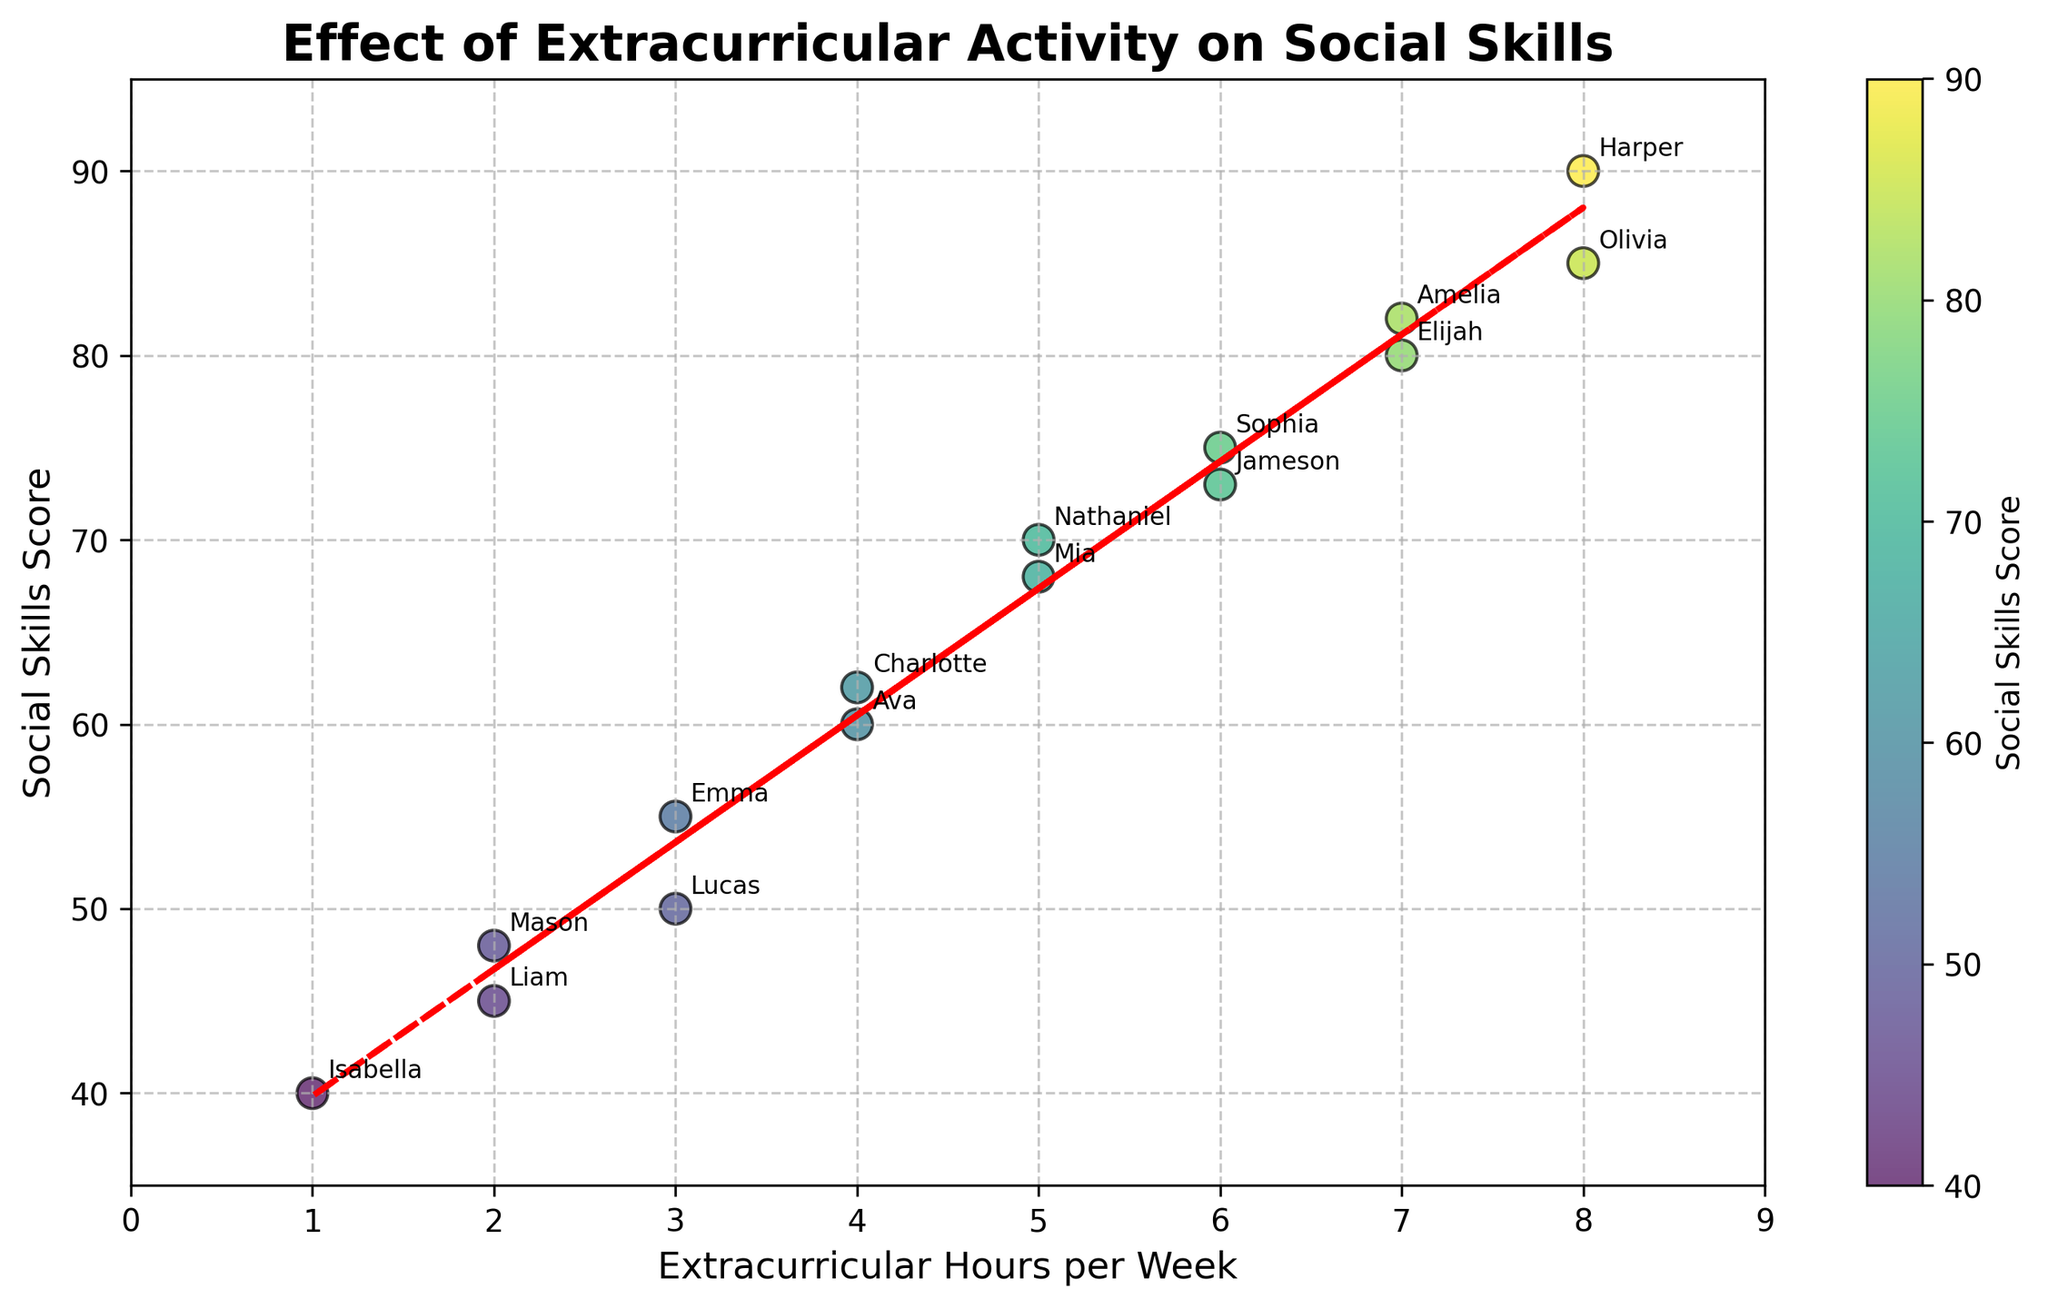How many data points are on the plot? Count the number of children listed in the data.
Answer: 15 What's the title of the plot? Read the title displayed at the top of the plot.
Answer: Effect of Extracurricular Activity on Social Skills Which axis indicates extracurricular hours per week? Determine which axis (horizontal or vertical) is labeled with "Extracurricular Hours per Week".
Answer: Horizontal (x-axis) Which child has the highest Social Skills Score? Look at all the data points and find the one with the highest score on the vertical axis.
Answer: Harper How many extracurricular hours does the child with the lowest Social Skills Score participate in? Identify the child with the lowest social skills score, then check their corresponding extracurricular hours on the horizontal axis.
Answer: 1 hour (Isabella) On average, how many extracurricular hours do children with a Social Skills Score above 75 participate in? Identify children with scores above 75, sum their extracurricular hours, and divide by the number of such children. The children are Olivia, Elijah, Amelia, and Harper, with hours 8, 7, 7, and 8 respectively. The sum is (8+7+7+8) = 30; the average is 30/4 = 7.5
Answer: 7.5 hours Which child has the closest Social Skills Score to Nathaniel? Compare the Social Skills Scores of all children with Nathaniel (who has a score of 70) and find the one with the closest score. Olivia (85), Emma (55), Olivia (8), Liam (45), Ava (60), Sophia (75), Elijah (80), Isabella (40), Lucas (50), Mia (68), Jameson (73), Charlotte (62), Amelia (82), Mason (48), Harper (90). The closest are Mia (68) and Sophia (75).
Answer: Mia (68) Is there a positive or negative correlation between Extracurricular Hours and Social Skills Score as indicated by the trend line? Observe the direction of the trend line. If it slopes upward from left to right, the correlation is positive. If it slopes downward, the correlation is negative.
Answer: Positive correlation Which children participate in 6 hours of extracurricular activities per week? Check the data points where the x-coordinate is 6 and read the corresponding names.
Answer: Sophia and Jameson By how many points does Harper's Social Skills Score exceed Lucas's? Identify the scores of Harper (90) and Lucas (50) and subtract the latter from the former. The difference is 90 - 50 = 40 points
Answer: 40 points 